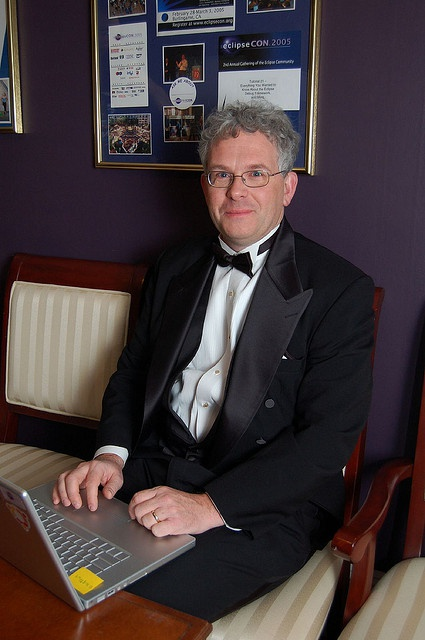Describe the objects in this image and their specific colors. I can see people in gray, black, salmon, and brown tones, chair in gray, black, darkgray, and maroon tones, couch in gray, darkgray, and black tones, laptop in gray, black, maroon, and darkgray tones, and chair in gray, black, maroon, and darkgray tones in this image. 